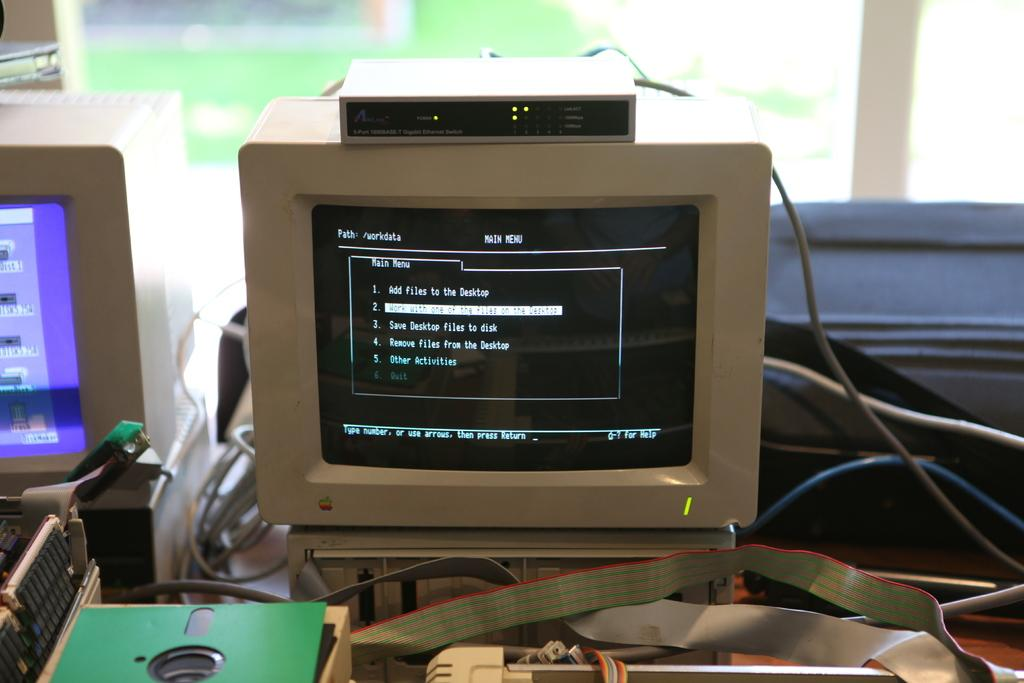What type of electronic devices are visible in the image? There are monitors in the image. What else can be seen in the image related to the monitors? There are cables in the image. What is the surface on which the monitors and cables are placed? There are objects on a table in the image. What can be seen in the background of the image? There is a glass window in the background of the image. What is the tendency of the nail to hold the objects on the table in the image? There is no nail present in the image, so it is not possible to determine its tendency to hold objects. 